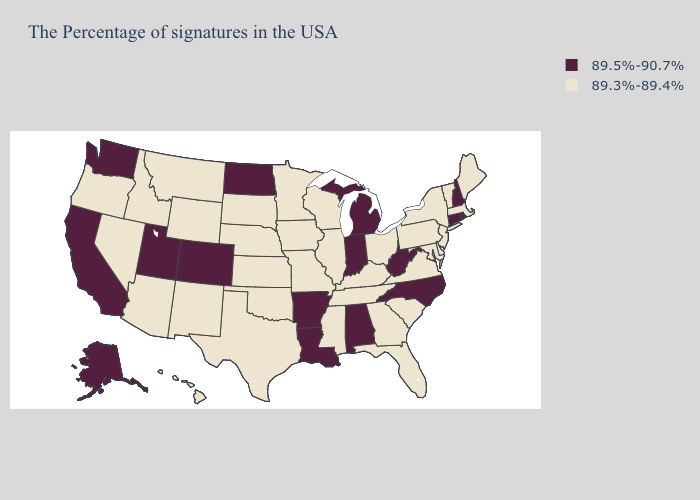What is the highest value in the Northeast ?
Give a very brief answer. 89.5%-90.7%. Does Delaware have the highest value in the USA?
Quick response, please. No. What is the value of Iowa?
Give a very brief answer. 89.3%-89.4%. What is the highest value in the USA?
Quick response, please. 89.5%-90.7%. What is the value of Maryland?
Write a very short answer. 89.3%-89.4%. Among the states that border Illinois , which have the highest value?
Keep it brief. Indiana. What is the lowest value in the USA?
Quick response, please. 89.3%-89.4%. What is the lowest value in the USA?
Concise answer only. 89.3%-89.4%. What is the lowest value in states that border Nevada?
Answer briefly. 89.3%-89.4%. Does Connecticut have the highest value in the USA?
Answer briefly. Yes. Does the first symbol in the legend represent the smallest category?
Give a very brief answer. No. What is the highest value in the USA?
Quick response, please. 89.5%-90.7%. What is the value of Massachusetts?
Concise answer only. 89.3%-89.4%. Which states have the highest value in the USA?
Concise answer only. Rhode Island, New Hampshire, Connecticut, North Carolina, West Virginia, Michigan, Indiana, Alabama, Louisiana, Arkansas, North Dakota, Colorado, Utah, California, Washington, Alaska. What is the highest value in states that border North Dakota?
Give a very brief answer. 89.3%-89.4%. 